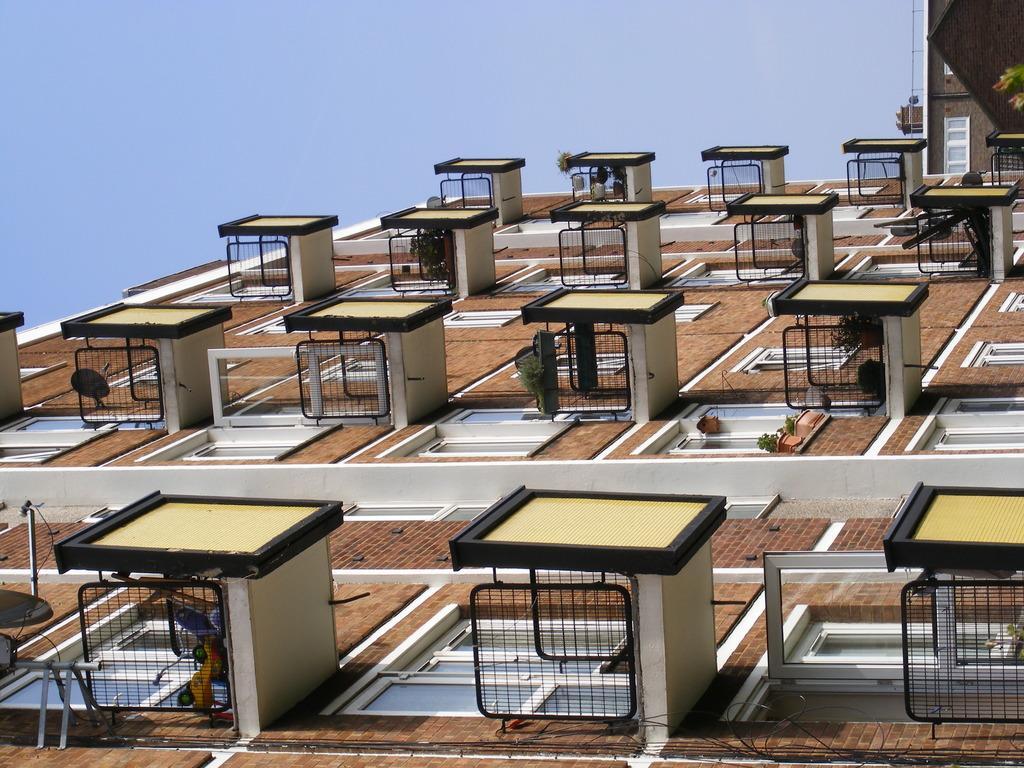Could you give a brief overview of what you see in this image? In this picture there is a buildings of different departments in the image. 